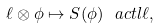Convert formula to latex. <formula><loc_0><loc_0><loc_500><loc_500>\ell \otimes \phi \mapsto S ( \phi ) \ a c t l \ell ,</formula> 